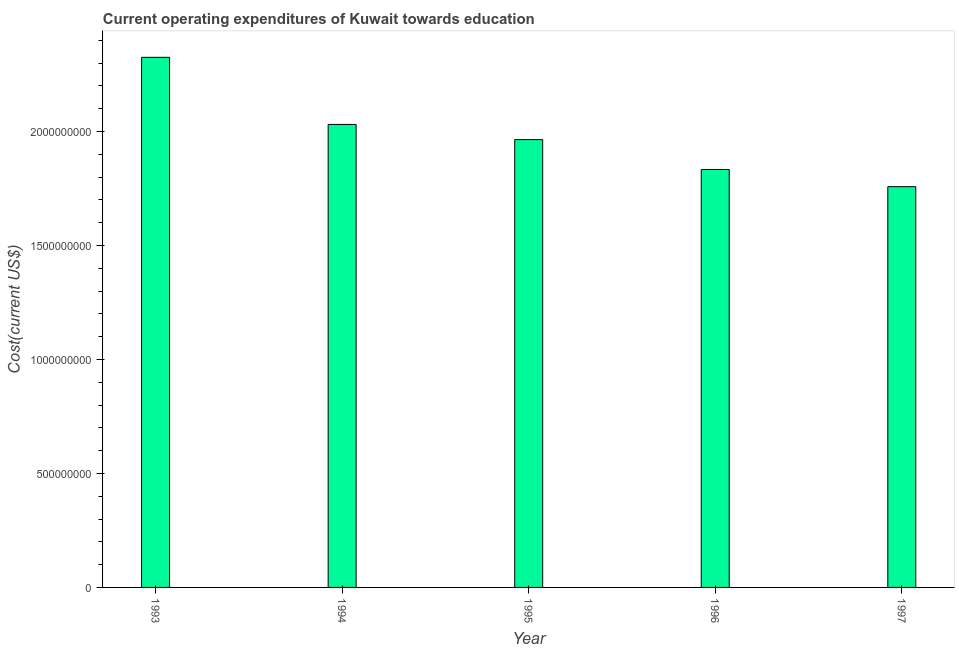Does the graph contain any zero values?
Make the answer very short. No. What is the title of the graph?
Provide a short and direct response. Current operating expenditures of Kuwait towards education. What is the label or title of the X-axis?
Ensure brevity in your answer.  Year. What is the label or title of the Y-axis?
Keep it short and to the point. Cost(current US$). What is the education expenditure in 1993?
Offer a very short reply. 2.33e+09. Across all years, what is the maximum education expenditure?
Provide a short and direct response. 2.33e+09. Across all years, what is the minimum education expenditure?
Your answer should be very brief. 1.76e+09. In which year was the education expenditure maximum?
Make the answer very short. 1993. What is the sum of the education expenditure?
Make the answer very short. 9.91e+09. What is the difference between the education expenditure in 1996 and 1997?
Give a very brief answer. 7.54e+07. What is the average education expenditure per year?
Keep it short and to the point. 1.98e+09. What is the median education expenditure?
Ensure brevity in your answer.  1.96e+09. What is the ratio of the education expenditure in 1994 to that in 1997?
Your answer should be compact. 1.16. Is the difference between the education expenditure in 1994 and 1997 greater than the difference between any two years?
Make the answer very short. No. What is the difference between the highest and the second highest education expenditure?
Provide a succinct answer. 2.94e+08. What is the difference between the highest and the lowest education expenditure?
Provide a succinct answer. 5.67e+08. In how many years, is the education expenditure greater than the average education expenditure taken over all years?
Your answer should be very brief. 2. How many years are there in the graph?
Your response must be concise. 5. What is the difference between two consecutive major ticks on the Y-axis?
Your answer should be very brief. 5.00e+08. What is the Cost(current US$) in 1993?
Give a very brief answer. 2.33e+09. What is the Cost(current US$) in 1994?
Give a very brief answer. 2.03e+09. What is the Cost(current US$) in 1995?
Offer a very short reply. 1.96e+09. What is the Cost(current US$) in 1996?
Provide a succinct answer. 1.83e+09. What is the Cost(current US$) of 1997?
Give a very brief answer. 1.76e+09. What is the difference between the Cost(current US$) in 1993 and 1994?
Offer a very short reply. 2.94e+08. What is the difference between the Cost(current US$) in 1993 and 1995?
Offer a terse response. 3.61e+08. What is the difference between the Cost(current US$) in 1993 and 1996?
Offer a very short reply. 4.92e+08. What is the difference between the Cost(current US$) in 1993 and 1997?
Your response must be concise. 5.67e+08. What is the difference between the Cost(current US$) in 1994 and 1995?
Keep it short and to the point. 6.67e+07. What is the difference between the Cost(current US$) in 1994 and 1996?
Your response must be concise. 1.98e+08. What is the difference between the Cost(current US$) in 1994 and 1997?
Make the answer very short. 2.73e+08. What is the difference between the Cost(current US$) in 1995 and 1996?
Your answer should be very brief. 1.31e+08. What is the difference between the Cost(current US$) in 1995 and 1997?
Make the answer very short. 2.06e+08. What is the difference between the Cost(current US$) in 1996 and 1997?
Make the answer very short. 7.54e+07. What is the ratio of the Cost(current US$) in 1993 to that in 1994?
Make the answer very short. 1.15. What is the ratio of the Cost(current US$) in 1993 to that in 1995?
Make the answer very short. 1.18. What is the ratio of the Cost(current US$) in 1993 to that in 1996?
Offer a very short reply. 1.27. What is the ratio of the Cost(current US$) in 1993 to that in 1997?
Your response must be concise. 1.32. What is the ratio of the Cost(current US$) in 1994 to that in 1995?
Your response must be concise. 1.03. What is the ratio of the Cost(current US$) in 1994 to that in 1996?
Ensure brevity in your answer.  1.11. What is the ratio of the Cost(current US$) in 1994 to that in 1997?
Provide a short and direct response. 1.16. What is the ratio of the Cost(current US$) in 1995 to that in 1996?
Offer a very short reply. 1.07. What is the ratio of the Cost(current US$) in 1995 to that in 1997?
Keep it short and to the point. 1.12. What is the ratio of the Cost(current US$) in 1996 to that in 1997?
Ensure brevity in your answer.  1.04. 